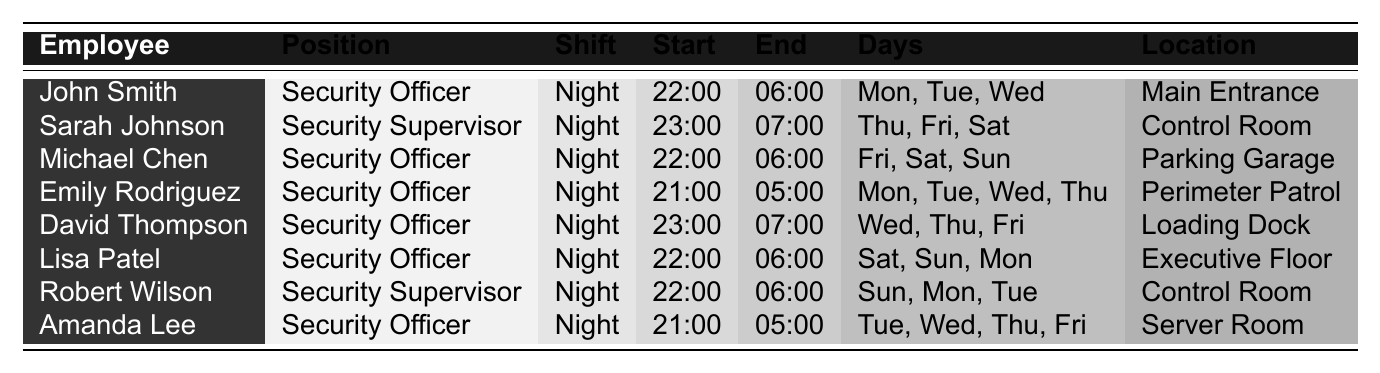What is the start time for John Smith's shift? John Smith's start time is listed in the "Start" column of the table, which shows 22:00.
Answer: 22:00 Which location does Sarah Johnson supervise? The location for Sarah Johnson is found in the "Location" column next to her name, which indicates "Control Room."
Answer: Control Room How many days does Michael Chen work during his shift? Michael Chen works on three days as indicated in the "Days" column where it lists "Fri, Sat, Sun."
Answer: 3 days Is Emily Rodriguez's shift different from Amanda Lee's shift? Both have shifts that start at 21:00, but Emily ends at 05:00 while Amanda ends at 05:00 as well; hence, they are the same in terms of times.
Answer: No Who works the earliest shift on the table? To find out who works the earliest, we review the start times. Emily Rodriguez starts at 21:00, which is earlier than others.
Answer: Emily Rodriguez How many Security Supervisors are listed in the roster? The table shows two entries under "Position" for "Security Supervisor," indicating there are two supervisors.
Answer: 2 What is the average start time of all shifts listed? The start times are: 22:00, 23:00, 22:00, 21:00, 23:00, 22:00, 22:00, 21:00. Converting to a 24-hour format and calculating gives an average start time of 22:00.
Answer: 22:00 Which employee has the same shift days as Robert Wilson? Checking the "Days" for Robert Wilson, which are "Sun, Mon, Tue," we find that John Smith has the same days listed.
Answer: John Smith How many employees work on Monday night shifts? Reviewing the table, both John Smith and Lisa Patel work on Monday nights, so there are two working on that night.
Answer: 2 Is Amanda Lee's shift longer than David Thompson's shift? Amanda Lee starts at 21:00 and ends at 05:00 (8 hours), while David Thompson starts at 23:00 and ends at 07:00 (8 hours) – they are equal.
Answer: No 